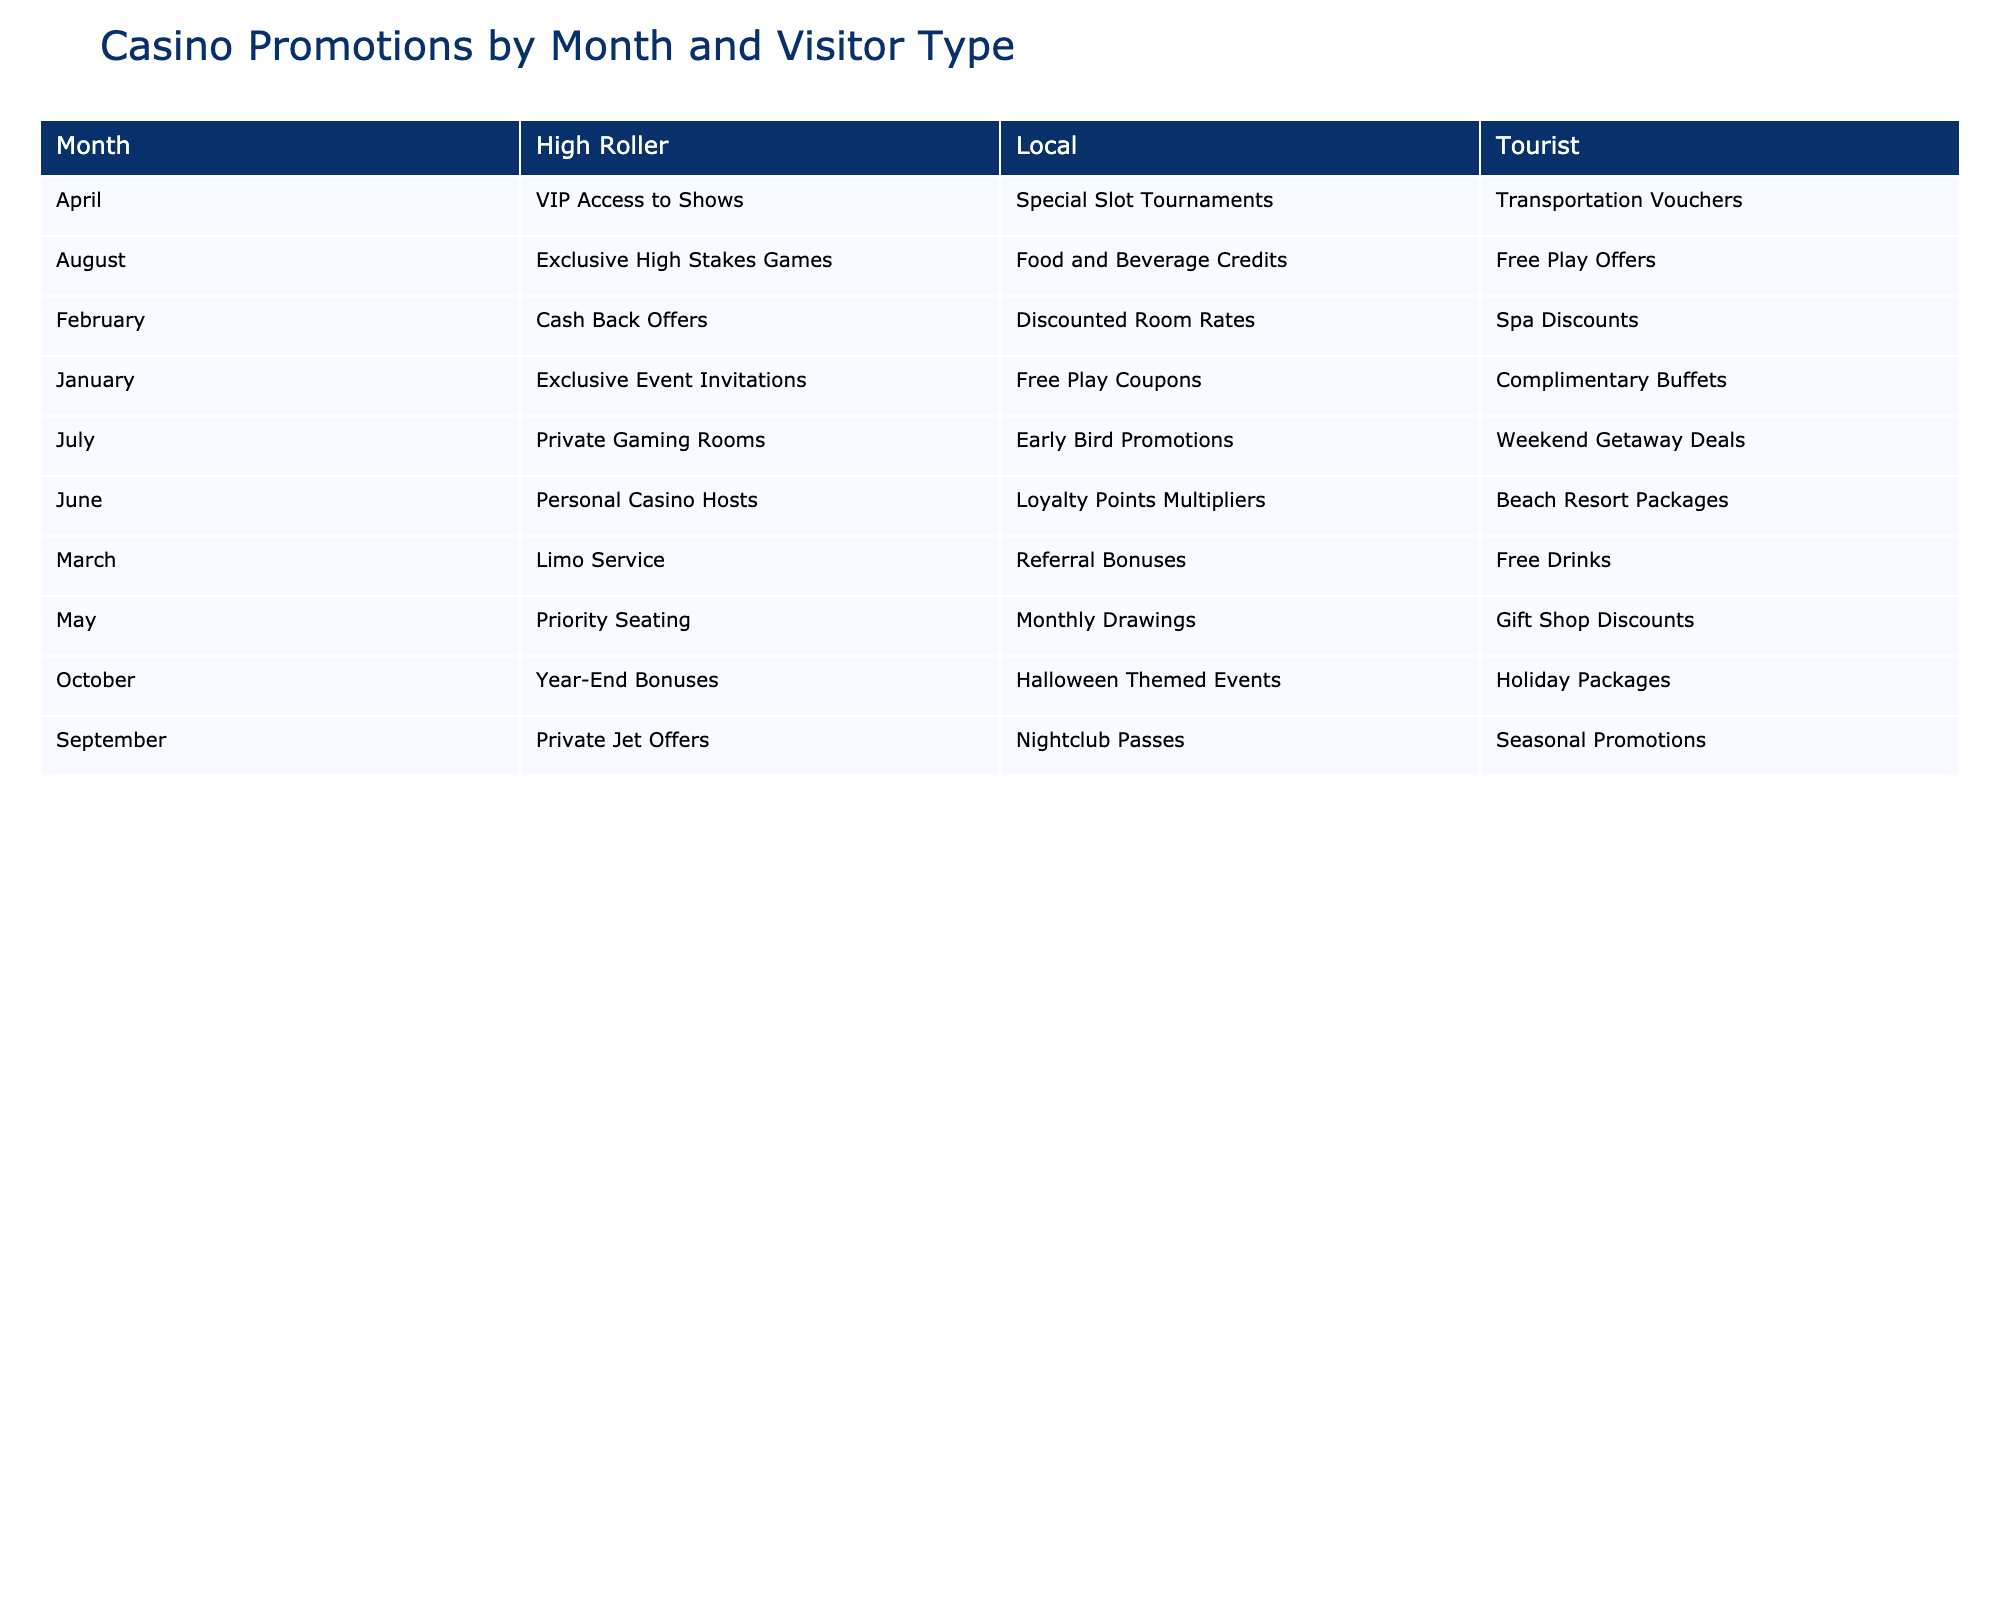What promotions were used by locals in March? By looking at the March row and the Local column in the table, the promotion listed is "Referral Bonuses."
Answer: Referral Bonuses Which visitor type used "Exclusive Event Invitations"? The table shows that "Exclusive Event Invitations" is listed under the High Roller column for January.
Answer: High Roller In which month did tourists use "Holiday Packages"? Referring to the table, "Holiday Packages" is found in the October row under the Tourist column.
Answer: October What is the total number of distinct promotions used by local visitors throughout the year? By reviewing the Local column in each month, the promotions are: Free Play Coupons, Discounted Room Rates, Referral Bonuses, Special Slot Tournaments, Monthly Drawings, Loyalty Points Multipliers, Early Bird Promotions, Food and Beverage Credits, Nightclub Passes, and Halloween Themed Events. There are 10 distinct promotions.
Answer: 10 Did high rollers use "Cash Back Offers" during any month? Looking at the table, "Cash Back Offers" is found under the High Roller column for February.
Answer: Yes Which visitor type had the highest number of promotions used in June? The table indicates that in June, the promotions are: Local - "Loyalty Points Multipliers," Tourist - "Beach Resort Packages," and High Roller - "Personal Casino Hosts." All visitor types only have one promotion each in June. Therefore, they all had the same count.
Answer: All visitor types had the same count Which month had the highest number of promotional types used by tourists? To find this, we look at the Tourist promotions in each month: January - 1, February - 1, March - 1, April - 1, May - 1, June - 1, July - 1, August - 1, September - 1, October - 1. Every month has one promotion for tourists, so there is no single month that stands out.
Answer: All months are equal Are "Private Gaming Rooms" used by any visitors? The table shows that "Private Gaming Rooms" is under the High Roller column for July.
Answer: Yes What is the average number of different promotions used by High Rollers? Reviewing the High Roller column, the promotions are: Exclusive Event Invitations (January), Cash Back Offers (February), Limo Service (March), VIP Access to Shows (April), Priority Seating (May), Personal Casino Hosts (June), Private Gaming Rooms (July), Exclusive High Stakes Games (August), Private Jet Offers (September), and Year-End Bonuses (October). This gives a total of 10 promotions for High Rollers. Since there's no month with more than one promotion for this visitor type, the average is 10/10 = 1.
Answer: 1 